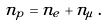Convert formula to latex. <formula><loc_0><loc_0><loc_500><loc_500>n _ { p } = n _ { e } + n _ { \mu } \, .</formula> 